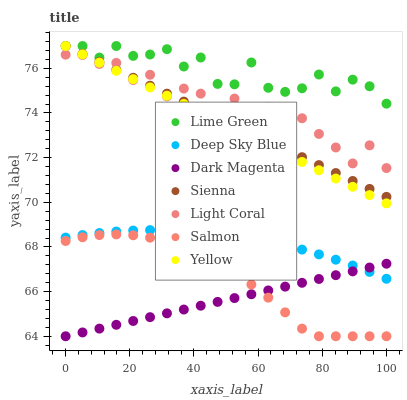Does Dark Magenta have the minimum area under the curve?
Answer yes or no. Yes. Does Lime Green have the maximum area under the curve?
Answer yes or no. Yes. Does Salmon have the minimum area under the curve?
Answer yes or no. No. Does Salmon have the maximum area under the curve?
Answer yes or no. No. Is Yellow the smoothest?
Answer yes or no. Yes. Is Light Coral the roughest?
Answer yes or no. Yes. Is Dark Magenta the smoothest?
Answer yes or no. No. Is Dark Magenta the roughest?
Answer yes or no. No. Does Dark Magenta have the lowest value?
Answer yes or no. Yes. Does Yellow have the lowest value?
Answer yes or no. No. Does Lime Green have the highest value?
Answer yes or no. Yes. Does Salmon have the highest value?
Answer yes or no. No. Is Deep Sky Blue less than Yellow?
Answer yes or no. Yes. Is Deep Sky Blue greater than Salmon?
Answer yes or no. Yes. Does Deep Sky Blue intersect Dark Magenta?
Answer yes or no. Yes. Is Deep Sky Blue less than Dark Magenta?
Answer yes or no. No. Is Deep Sky Blue greater than Dark Magenta?
Answer yes or no. No. Does Deep Sky Blue intersect Yellow?
Answer yes or no. No. 